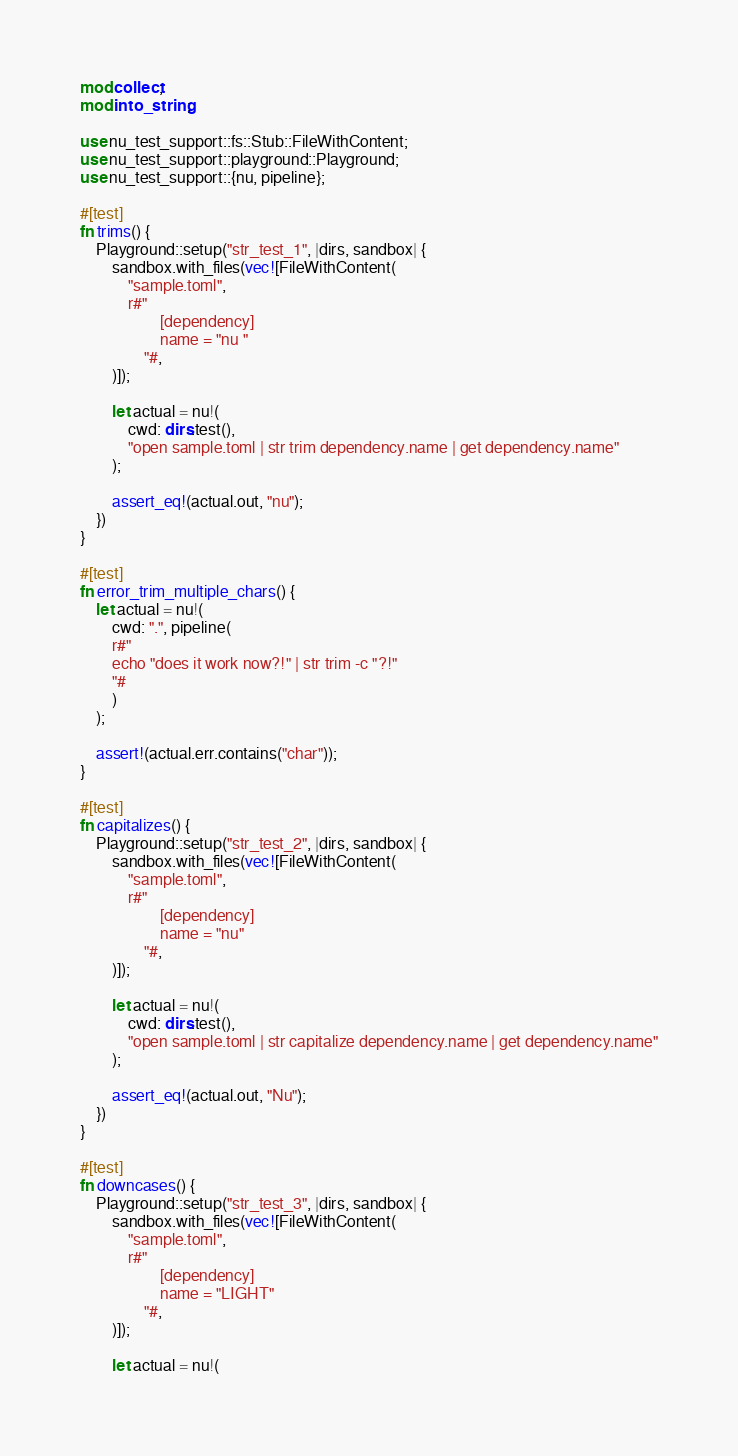Convert code to text. <code><loc_0><loc_0><loc_500><loc_500><_Rust_>mod collect;
mod into_string;

use nu_test_support::fs::Stub::FileWithContent;
use nu_test_support::playground::Playground;
use nu_test_support::{nu, pipeline};

#[test]
fn trims() {
    Playground::setup("str_test_1", |dirs, sandbox| {
        sandbox.with_files(vec![FileWithContent(
            "sample.toml",
            r#"
                    [dependency]
                    name = "nu "
                "#,
        )]);

        let actual = nu!(
            cwd: dirs.test(),
            "open sample.toml | str trim dependency.name | get dependency.name"
        );

        assert_eq!(actual.out, "nu");
    })
}

#[test]
fn error_trim_multiple_chars() {
    let actual = nu!(
        cwd: ".", pipeline(
        r#"
        echo "does it work now?!" | str trim -c "?!"
        "#
        )
    );

    assert!(actual.err.contains("char"));
}

#[test]
fn capitalizes() {
    Playground::setup("str_test_2", |dirs, sandbox| {
        sandbox.with_files(vec![FileWithContent(
            "sample.toml",
            r#"
                    [dependency]
                    name = "nu"
                "#,
        )]);

        let actual = nu!(
            cwd: dirs.test(),
            "open sample.toml | str capitalize dependency.name | get dependency.name"
        );

        assert_eq!(actual.out, "Nu");
    })
}

#[test]
fn downcases() {
    Playground::setup("str_test_3", |dirs, sandbox| {
        sandbox.with_files(vec![FileWithContent(
            "sample.toml",
            r#"
                    [dependency]
                    name = "LIGHT"
                "#,
        )]);

        let actual = nu!(</code> 